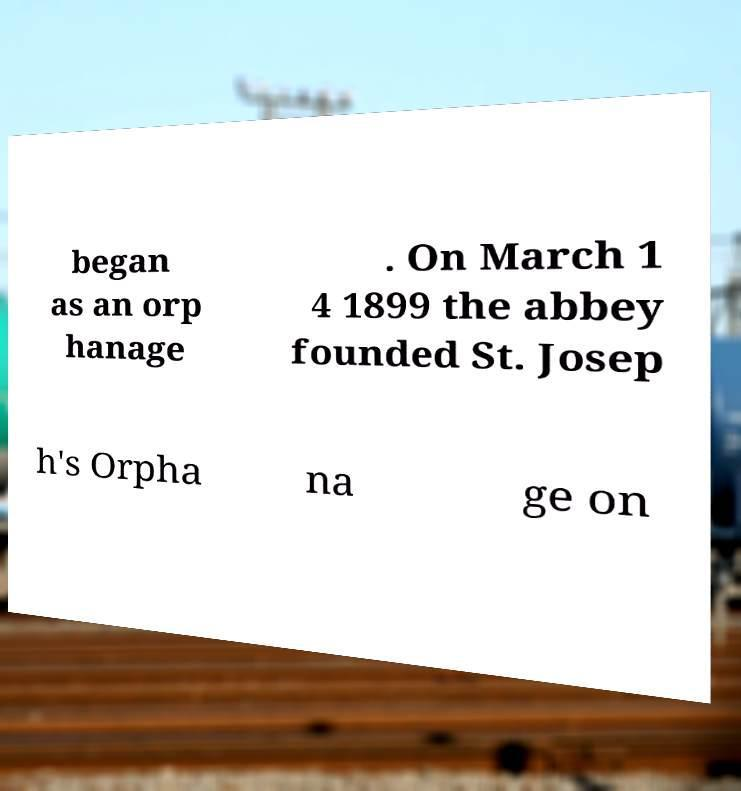What messages or text are displayed in this image? I need them in a readable, typed format. began as an orp hanage . On March 1 4 1899 the abbey founded St. Josep h's Orpha na ge on 